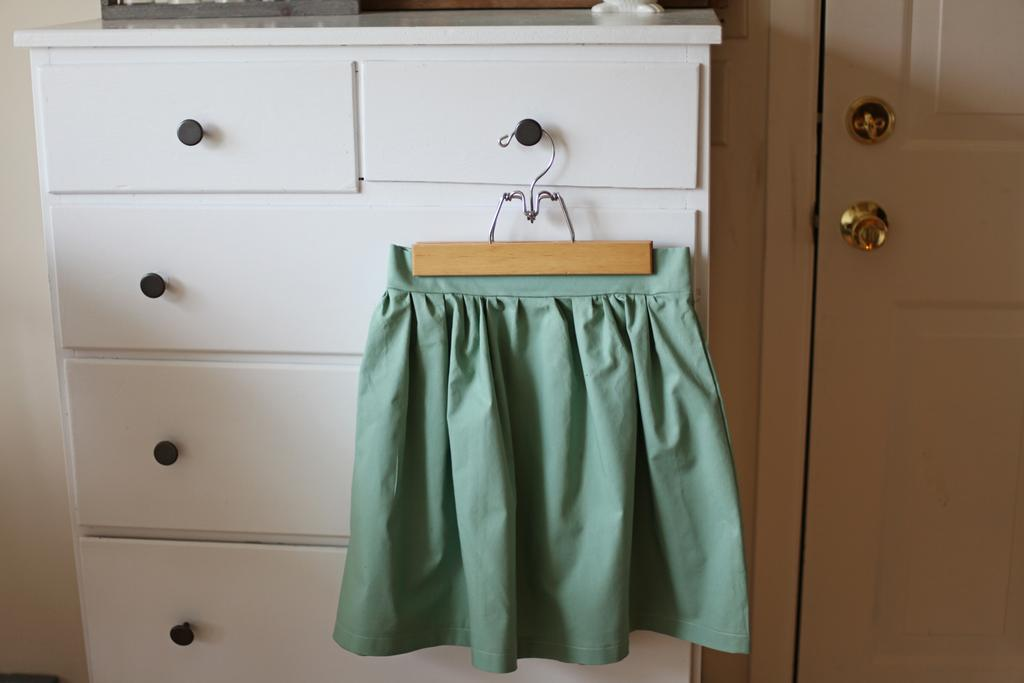What is hanging on the cupboard rack in the image? There is a cloth hanging on a cupboard rack in the image. What type of structure can be seen in the image? There is a door in the image. What is the background of the image made of? There is a wall in the image. How are the books arranged on the tail in the image? There are no books or tails present in the image. 